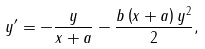Convert formula to latex. <formula><loc_0><loc_0><loc_500><loc_500>y ^ { \prime } = - \frac { y } { x + a } - \frac { b \left ( x + a \right ) y ^ { 2 } } { 2 } ,</formula> 